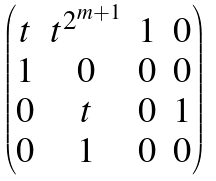<formula> <loc_0><loc_0><loc_500><loc_500>\begin{pmatrix} t & t ^ { 2 ^ { m + 1 } } & 1 & 0 \\ 1 & 0 & 0 & 0 \\ 0 & t & 0 & 1 \\ 0 & 1 & 0 & 0 \end{pmatrix}</formula> 